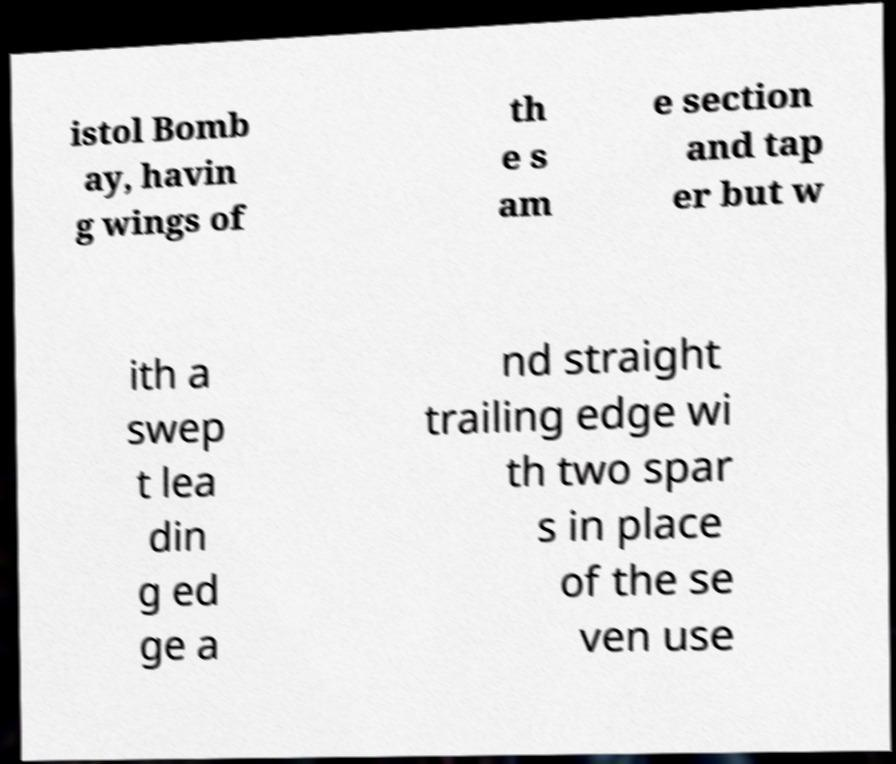Could you extract and type out the text from this image? istol Bomb ay, havin g wings of th e s am e section and tap er but w ith a swep t lea din g ed ge a nd straight trailing edge wi th two spar s in place of the se ven use 